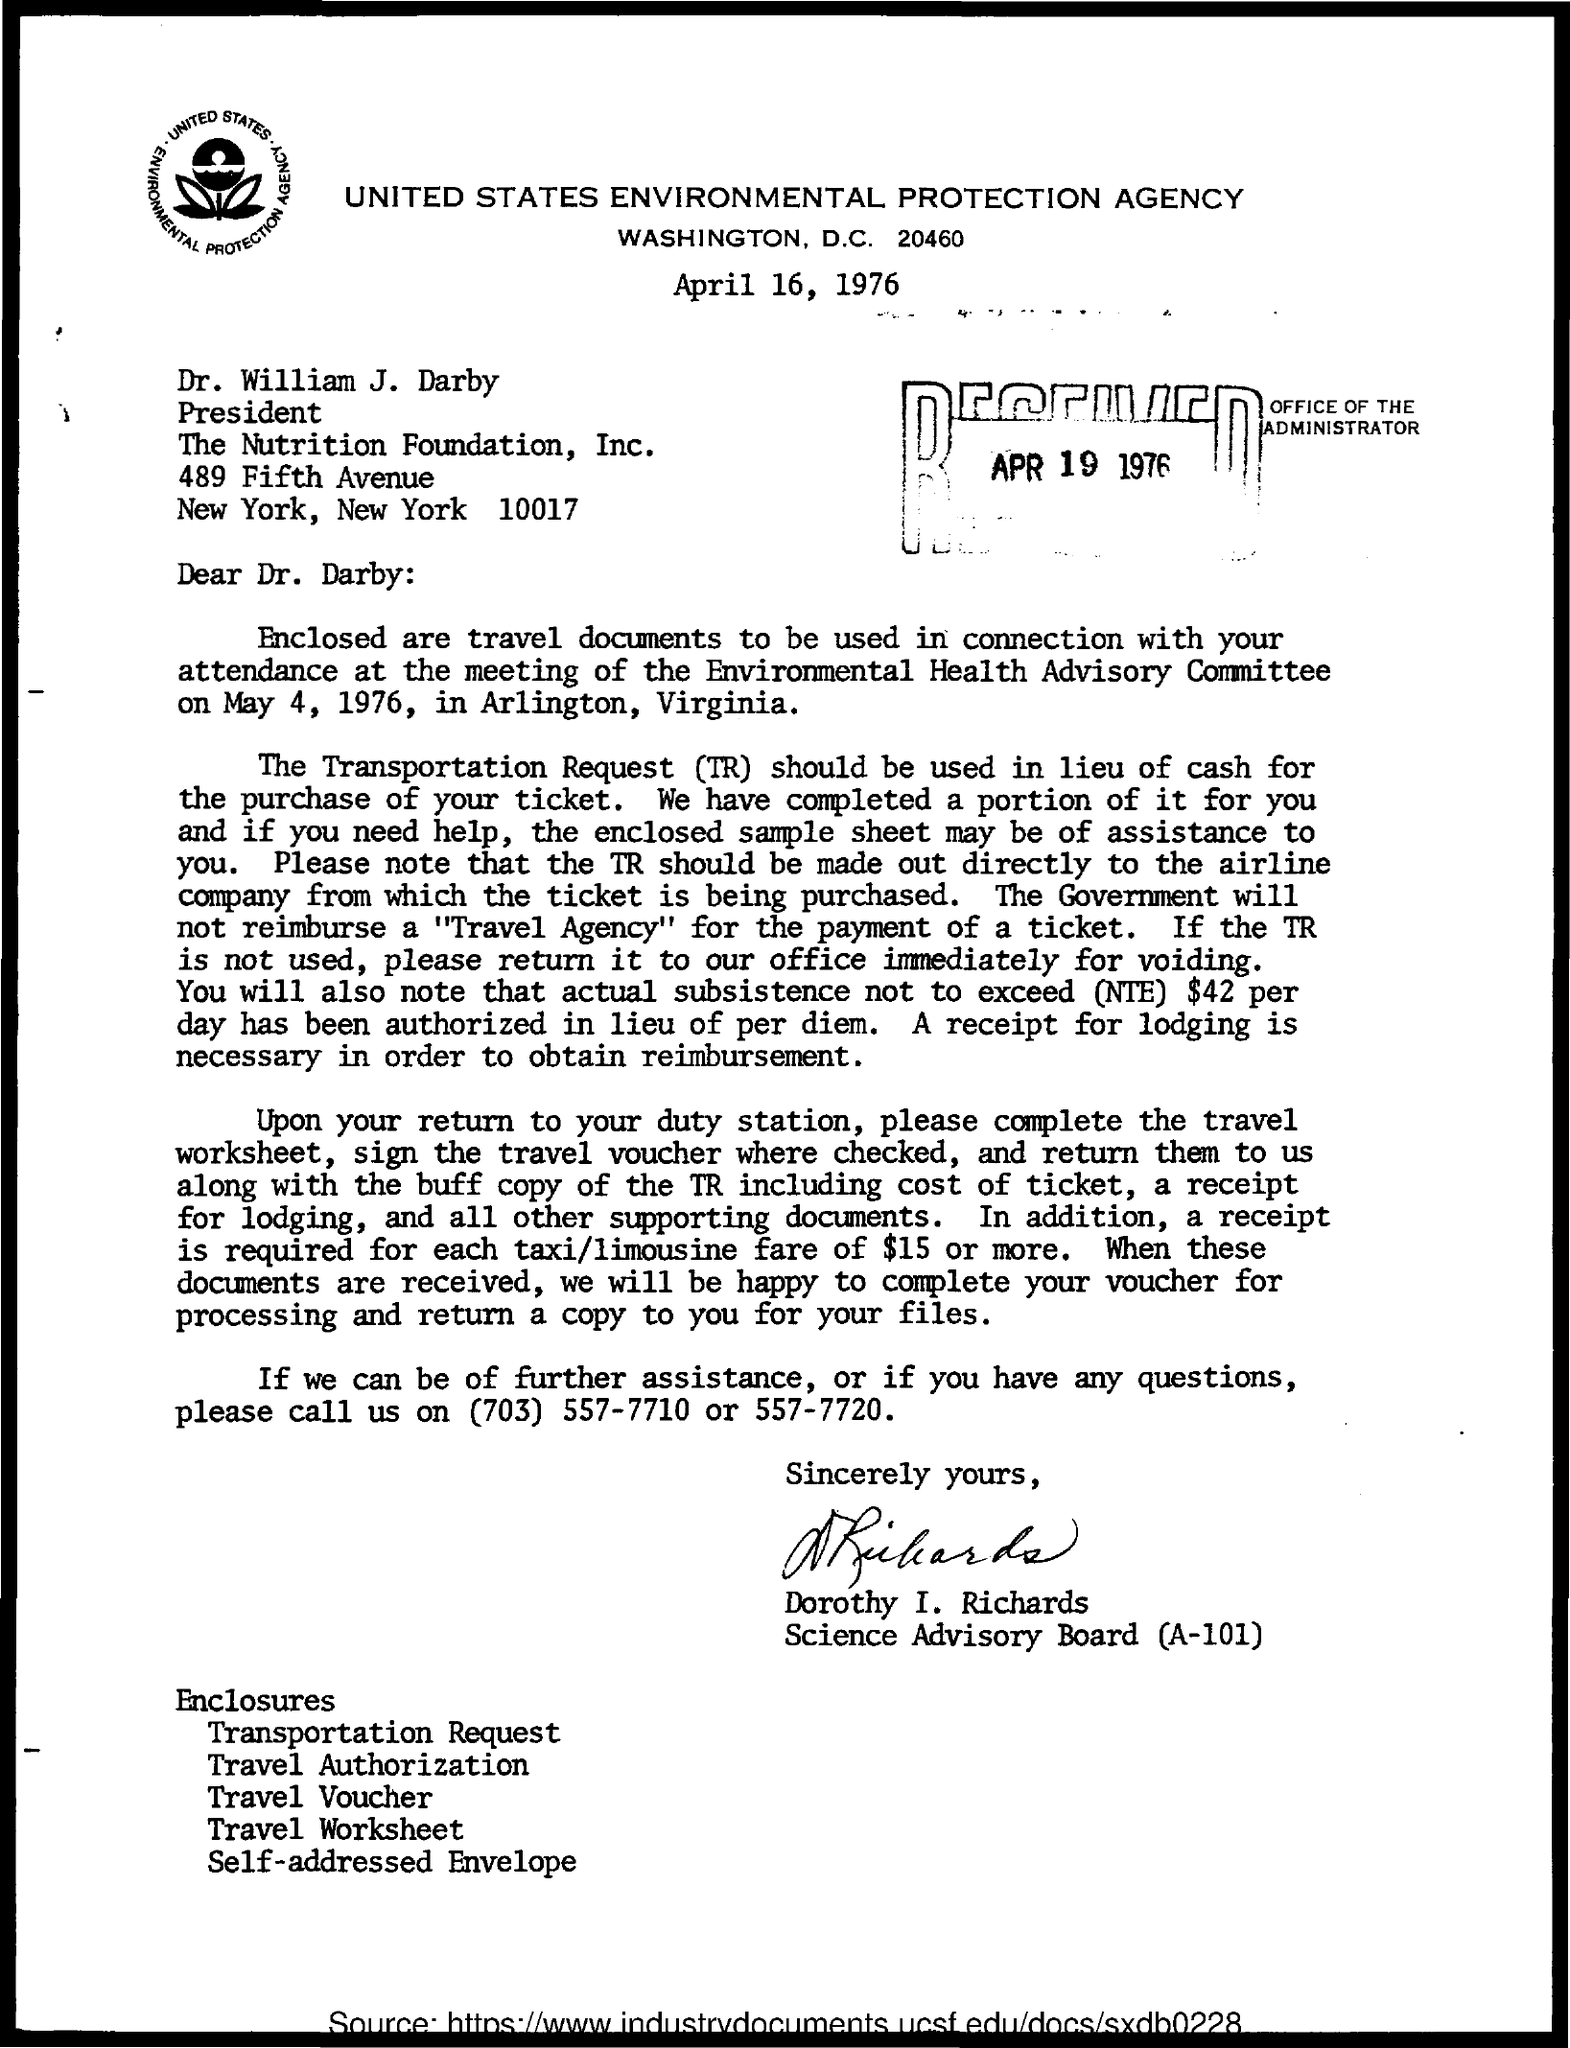Who is the president of the nutrition foundation , inc
Provide a short and direct response. Dr. William J. Darby. What is the date of meeting of the environmental health advisory committee
Offer a terse response. May 4, 1976. 